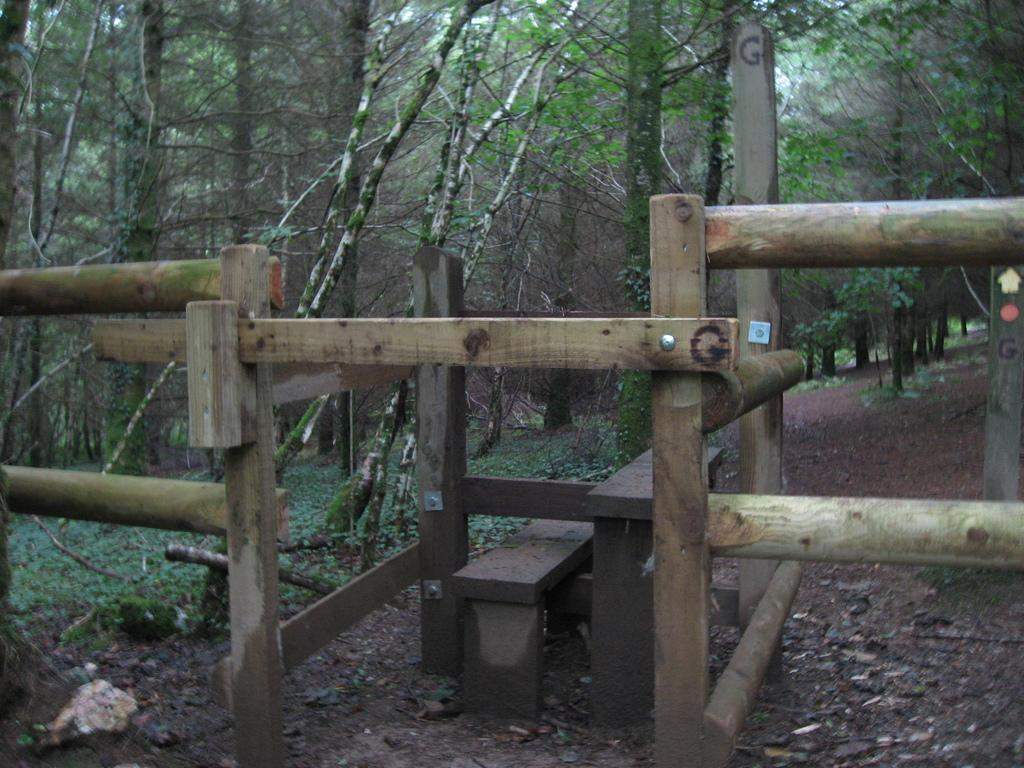What type of trees can be seen in the image? There are green color trees in the image. What kind of structure is present in the image? There is a wooden structure in the image. What type of fang can be seen in the image? There is no fang present in the image. What advertisement is being displayed on the trees in the image? There is no advertisement present in the image; it only features trees and a wooden structure. 